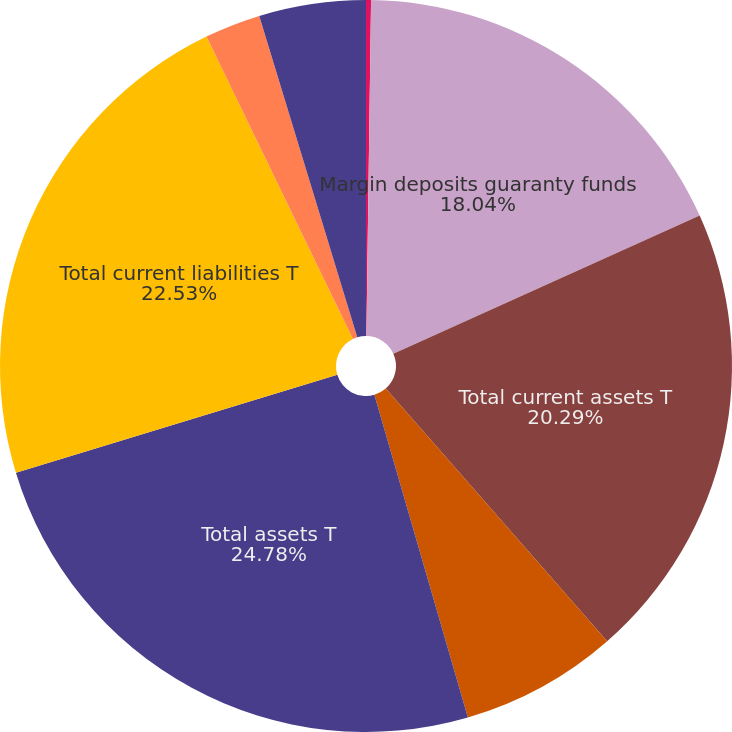Convert chart. <chart><loc_0><loc_0><loc_500><loc_500><pie_chart><fcel>Cash and cash equivalents<fcel>Margin deposits guaranty funds<fcel>Total current assets T<fcel>Goodwill and other intangible<fcel>Total assets T<fcel>Total current liabilities T<fcel>Short-term and long-term<fcel>Equity (2)<nl><fcel>0.22%<fcel>18.04%<fcel>20.29%<fcel>6.96%<fcel>24.78%<fcel>22.53%<fcel>2.47%<fcel>4.71%<nl></chart> 